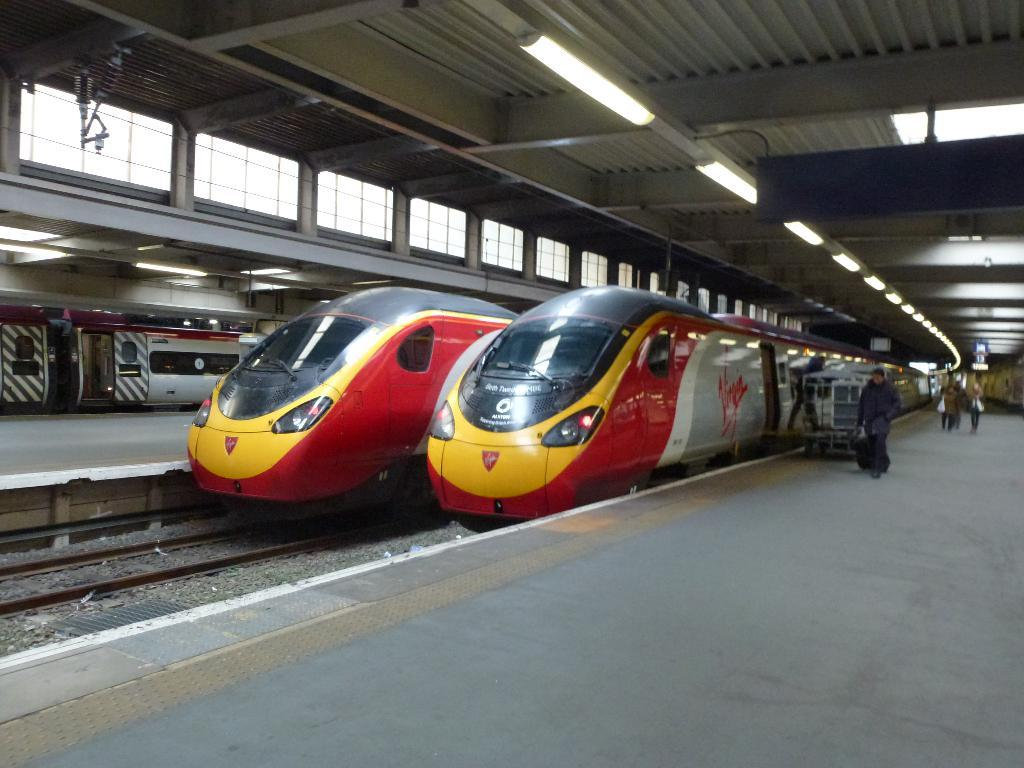<image>
Create a compact narrative representing the image presented. a train with a Virgin ad on the side of it 